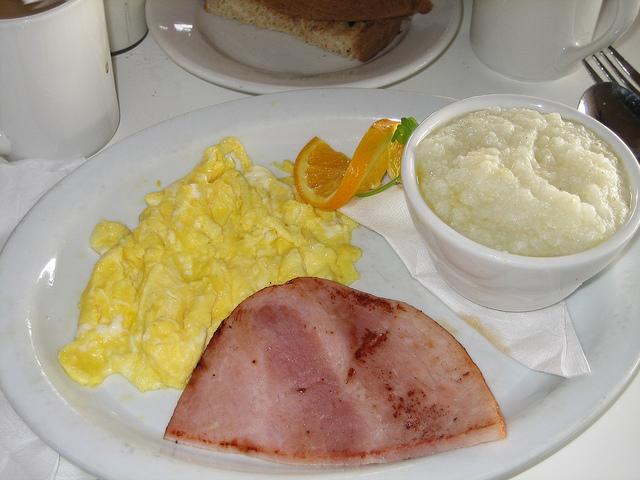What is in the bowl?
Keep it brief. Grits. What color is the plate?
Keep it brief. White. What meal of the day is this?
Write a very short answer. Breakfast. 